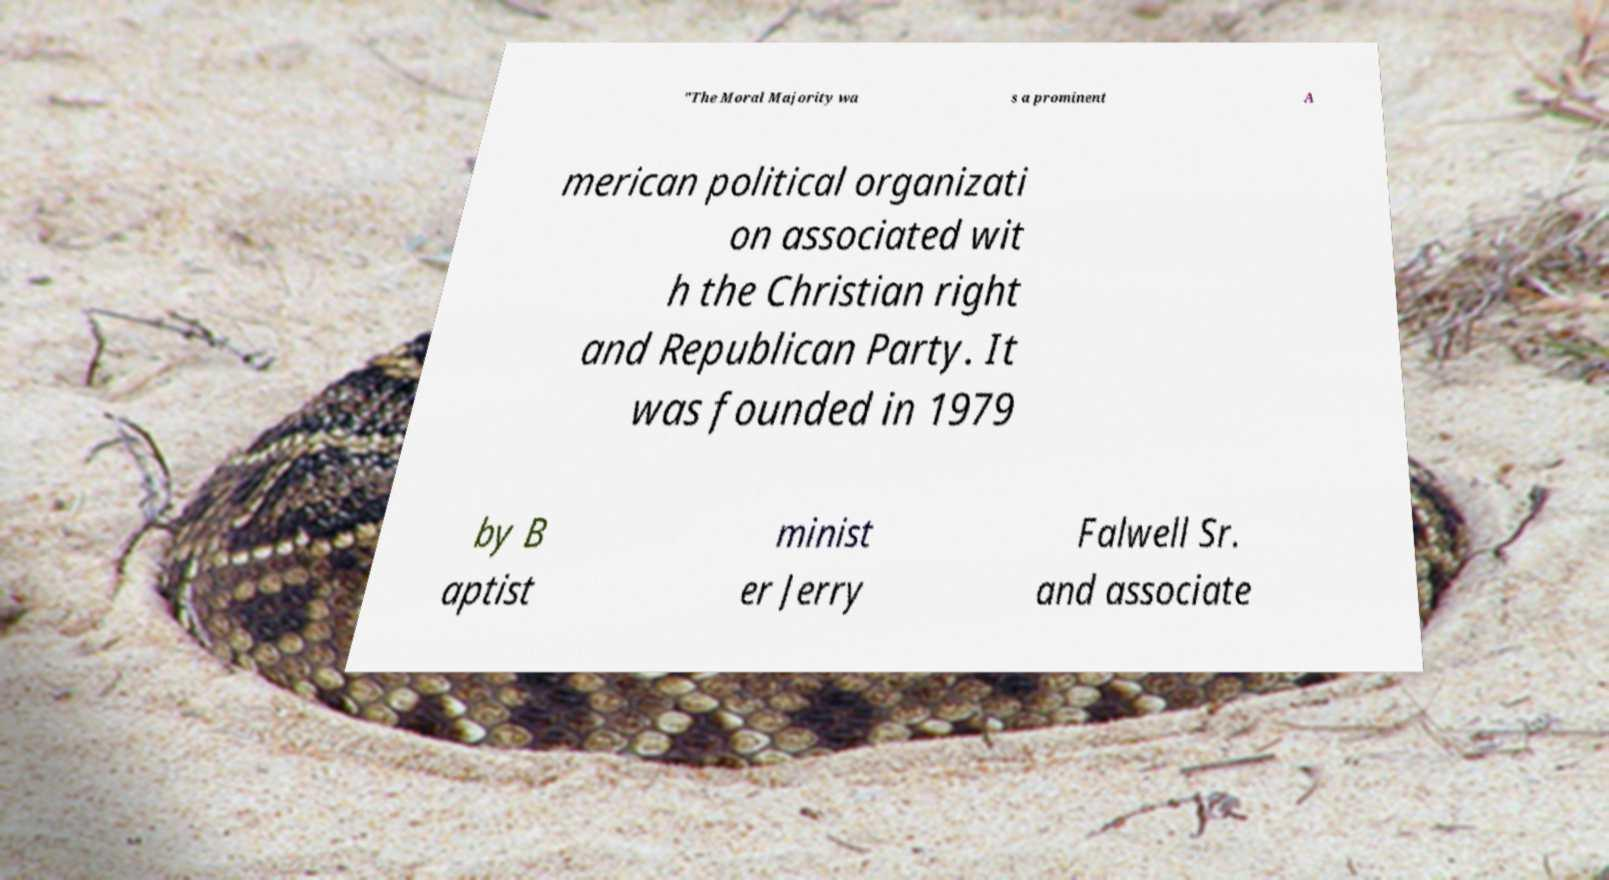Can you accurately transcribe the text from the provided image for me? "The Moral Majority wa s a prominent A merican political organizati on associated wit h the Christian right and Republican Party. It was founded in 1979 by B aptist minist er Jerry Falwell Sr. and associate 